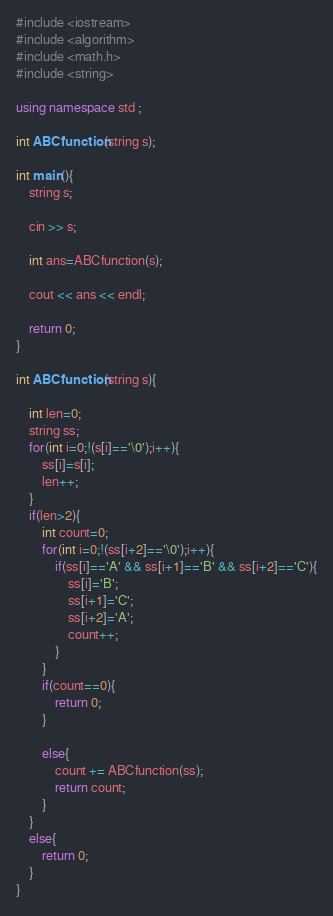Convert code to text. <code><loc_0><loc_0><loc_500><loc_500><_C++_>#include <iostream>
#include <algorithm>
#include <math.h>
#include <string>

using namespace std ;

int ABCfunction(string s);

int main(){
    string s;

    cin >> s;

    int ans=ABCfunction(s);

    cout << ans << endl;

    return 0;
}

int ABCfunction(string s){

    int len=0;
    string ss;
    for(int i=0;!(s[i]=='\0');i++){
        ss[i]=s[i];
        len++;
    }
    if(len>2){
        int count=0;
        for(int i=0;!(ss[i+2]=='\0');i++){
            if(ss[i]=='A' && ss[i+1]=='B' && ss[i+2]=='C'){
                ss[i]='B';
                ss[i+1]='C';
                ss[i+2]='A';
                count++;
            }
        }
        if(count==0){
            return 0;
        }

        else{
            count += ABCfunction(ss);
            return count;
        }
    }
    else{
        return 0;
    }
}</code> 